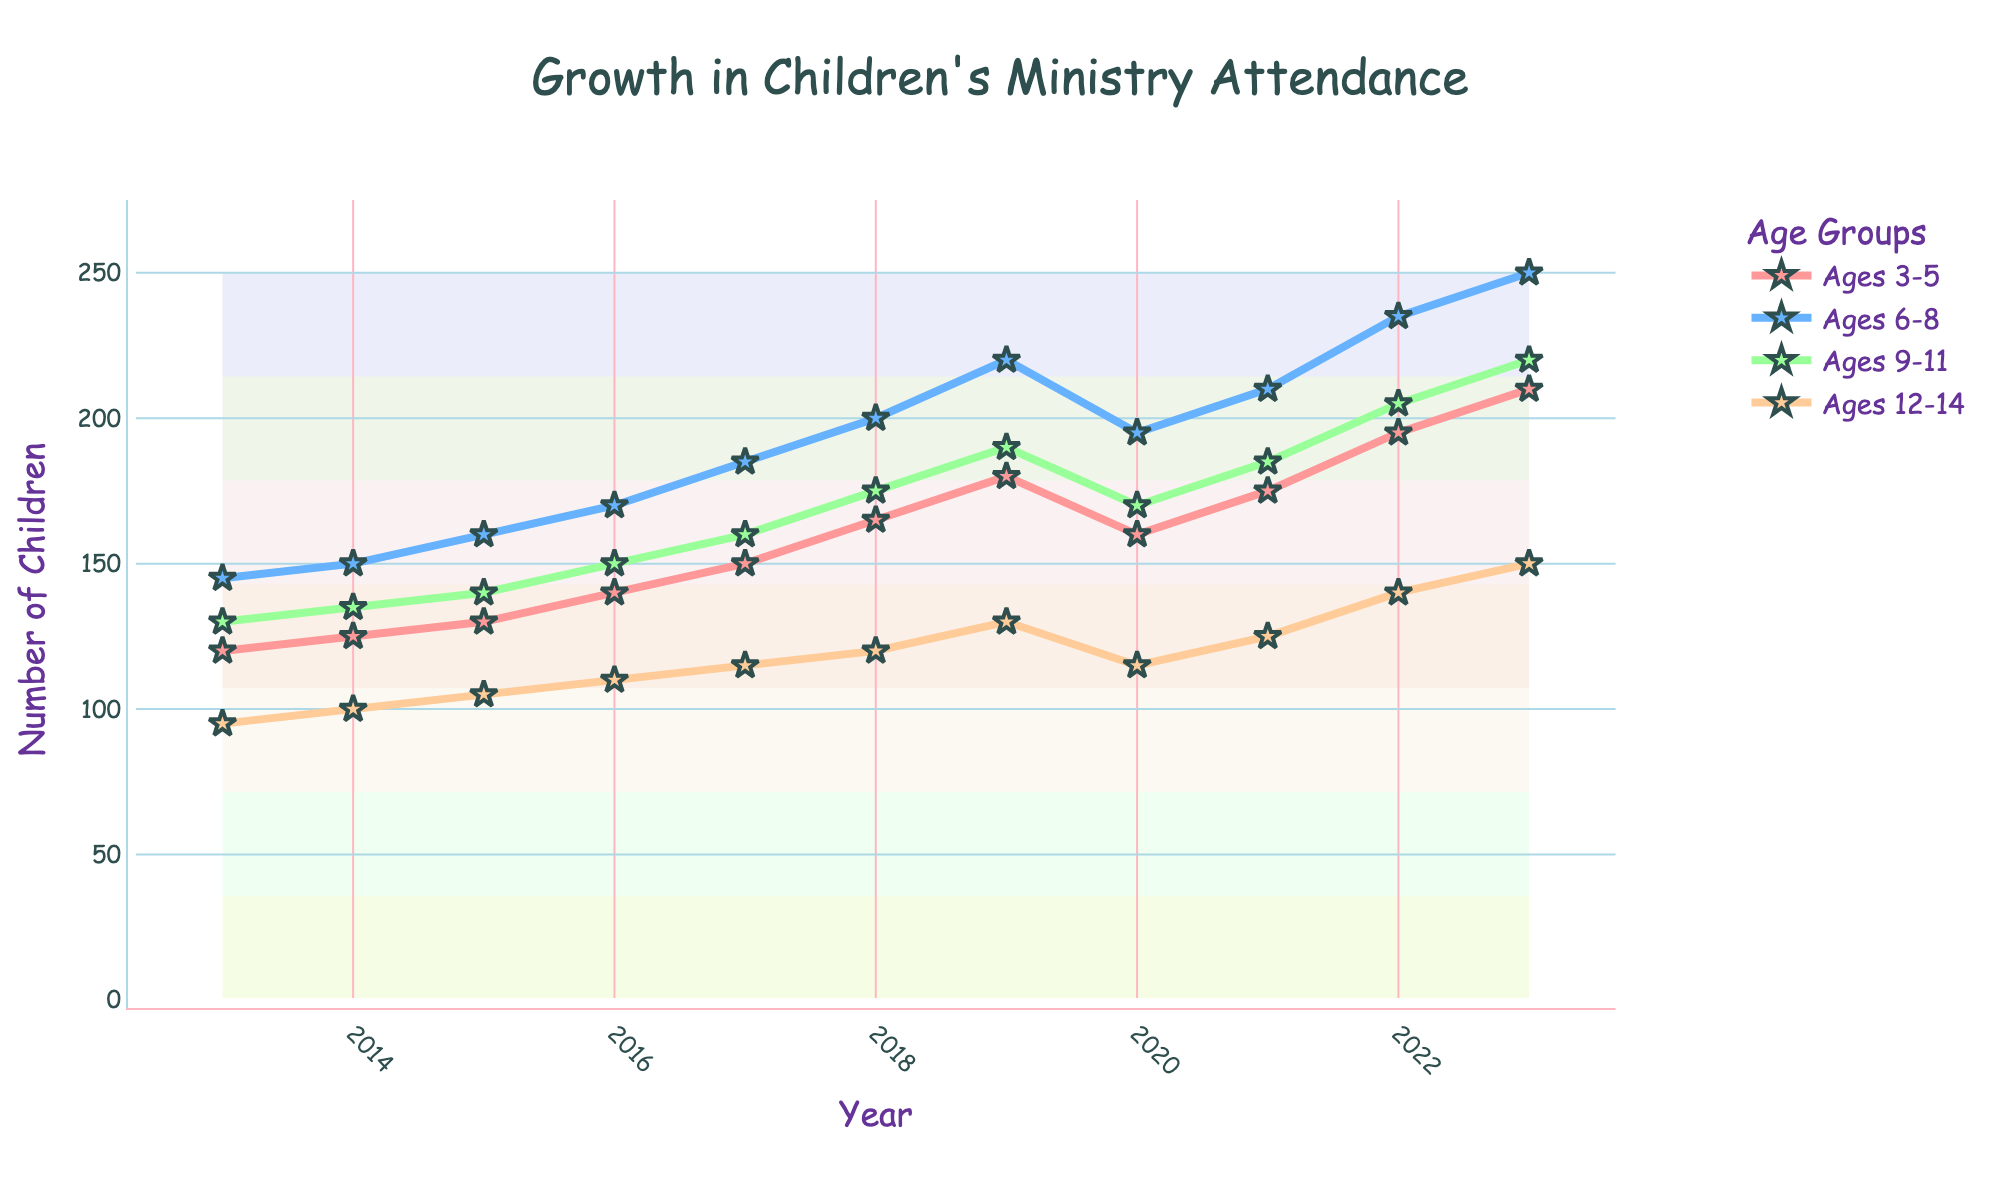What year saw the highest attendance in the 9-11 age group? First, locate the line corresponding to the 9-11 age group (green line). Then identify the highest point on this line and note the year.
Answer: 2023 Which age group had the most significant increase in attendees from 2013 to 2023? Find the difference in attendance for each age group between 2013 and 2023. Calculate the increase for Ages 3-5, Ages 6-8, Ages 9-11, and Ages 12-14, then compare them.
Answer: Ages 6-8 What was the average attendance for the Ages 12-14 group over the decade? Sum the attendance numbers for Ages 12-14 from 2013 to 2023 and divide by the number of years (11). The calculation is (95+100+105+110+115+120+130+115+125+140+150)/11.
Answer: 118.18 How did the attendance for Ages 6-8 compare from 2019 to 2020? Locate the values for Ages 6-8 in 2019 and 2020. Note the attendance in 2019 was 220 and in 2020 it was 195. Calculate the difference (220 - 195).
Answer: Decreased by 25 Between which two consecutive years did the Ages 3-5 group see the most significant growth? Inspect the change in attendance for Ages 3-5 between every consecutive pair of years and identify the largest increase.
Answer: 2021 to 2022 What visual attribute distinguishes the Ages 12-14 group in the chart? Look at the lines and markers for each age group. Notice the characteristics that set the Ages 12-14 group apart, such as the color and marker style.
Answer: Orange line with star markers What is the total attendance for all age groups in 2023? Sum the attendance of all age groups for the year 2023: 210 (Ages 3-5) + 250 (Ages 6-8) + 220 (Ages 9-11) + 150 (Ages 12-14).
Answer: 830 During which years did all age groups experience a decline in attendance? Look for years where the values of all age groups are lower than the previous year. Identify these years on the chart.
Answer: 2020 